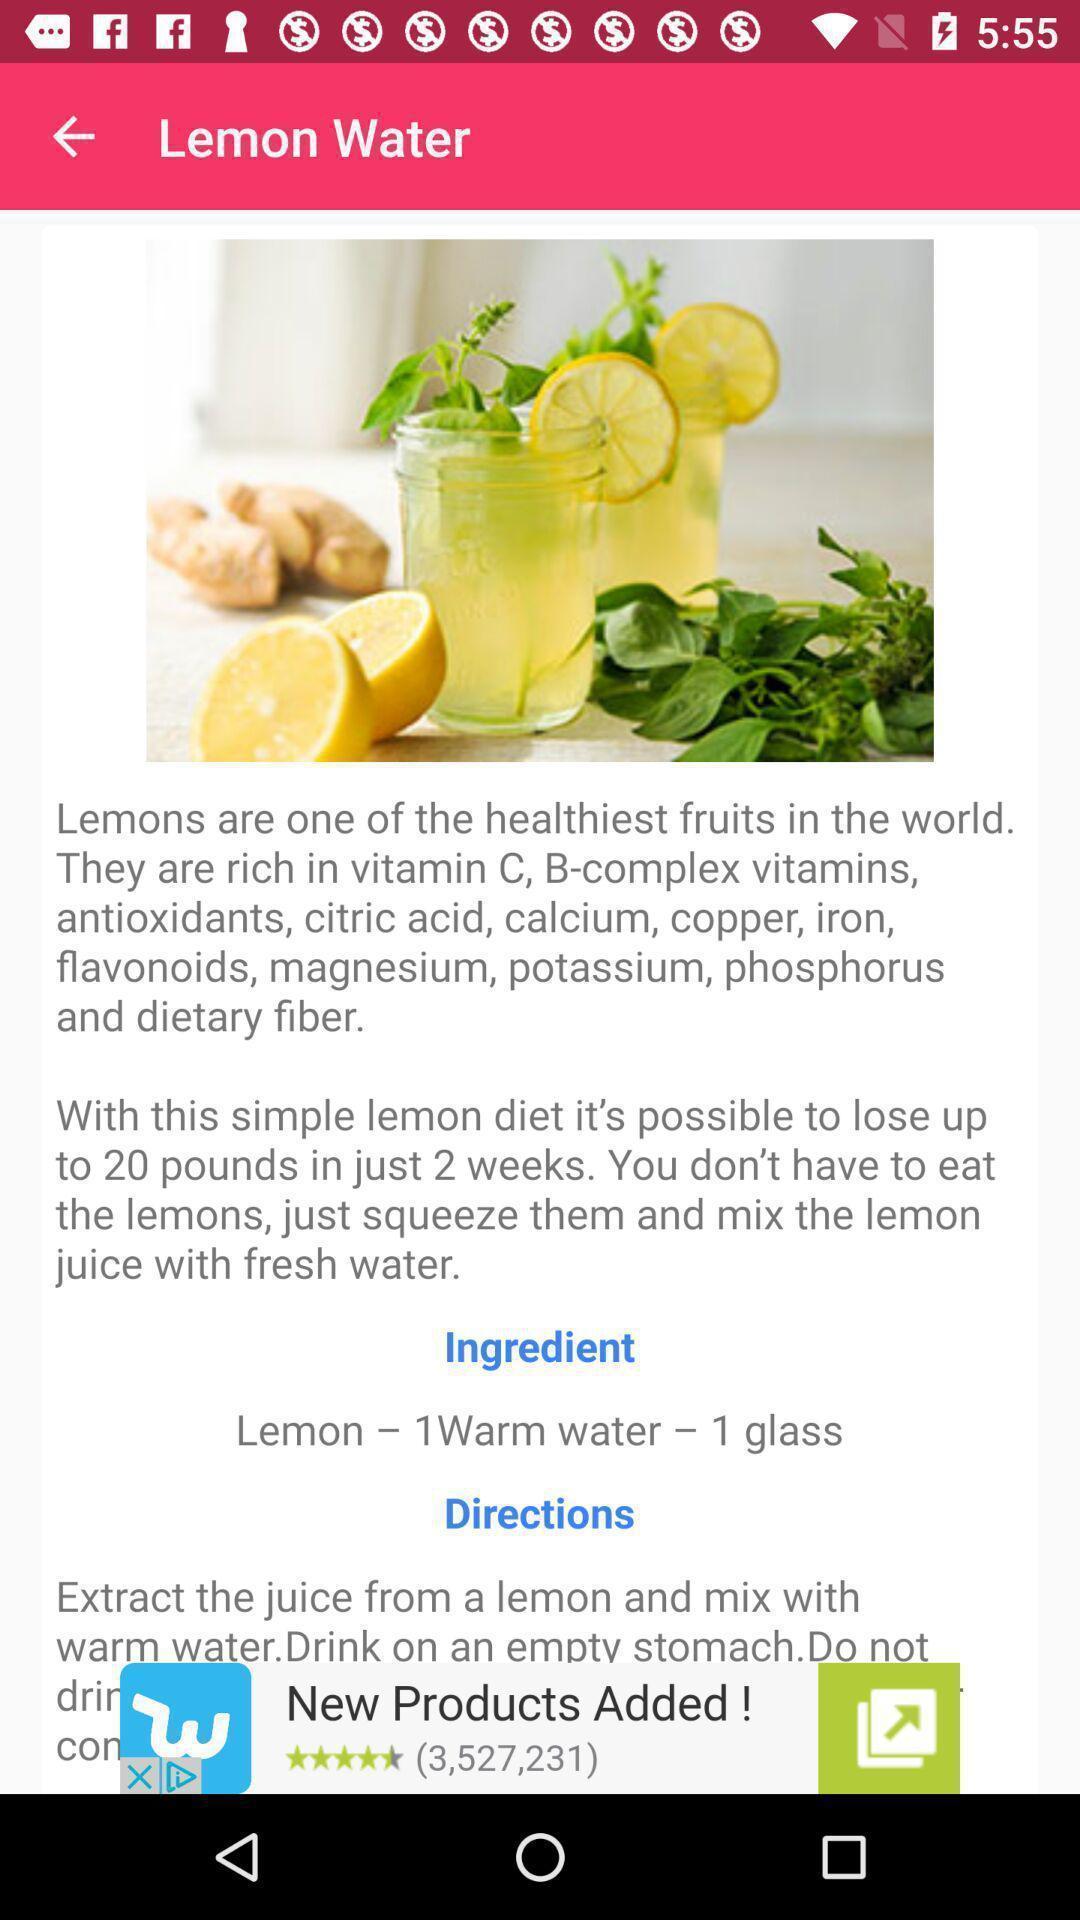What details can you identify in this image? Page displaying information about lemon water. 